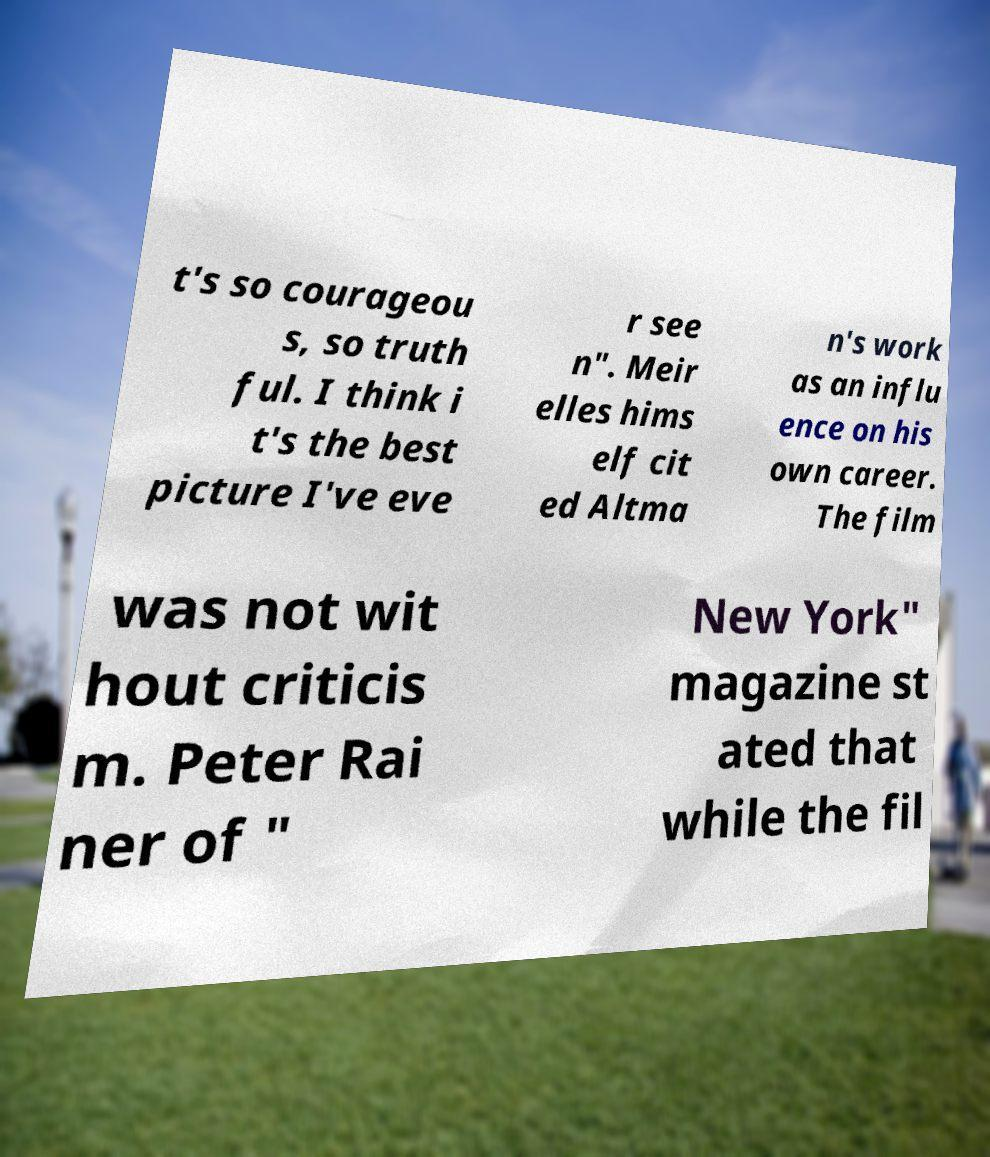Could you assist in decoding the text presented in this image and type it out clearly? t's so courageou s, so truth ful. I think i t's the best picture I've eve r see n". Meir elles hims elf cit ed Altma n's work as an influ ence on his own career. The film was not wit hout criticis m. Peter Rai ner of " New York" magazine st ated that while the fil 